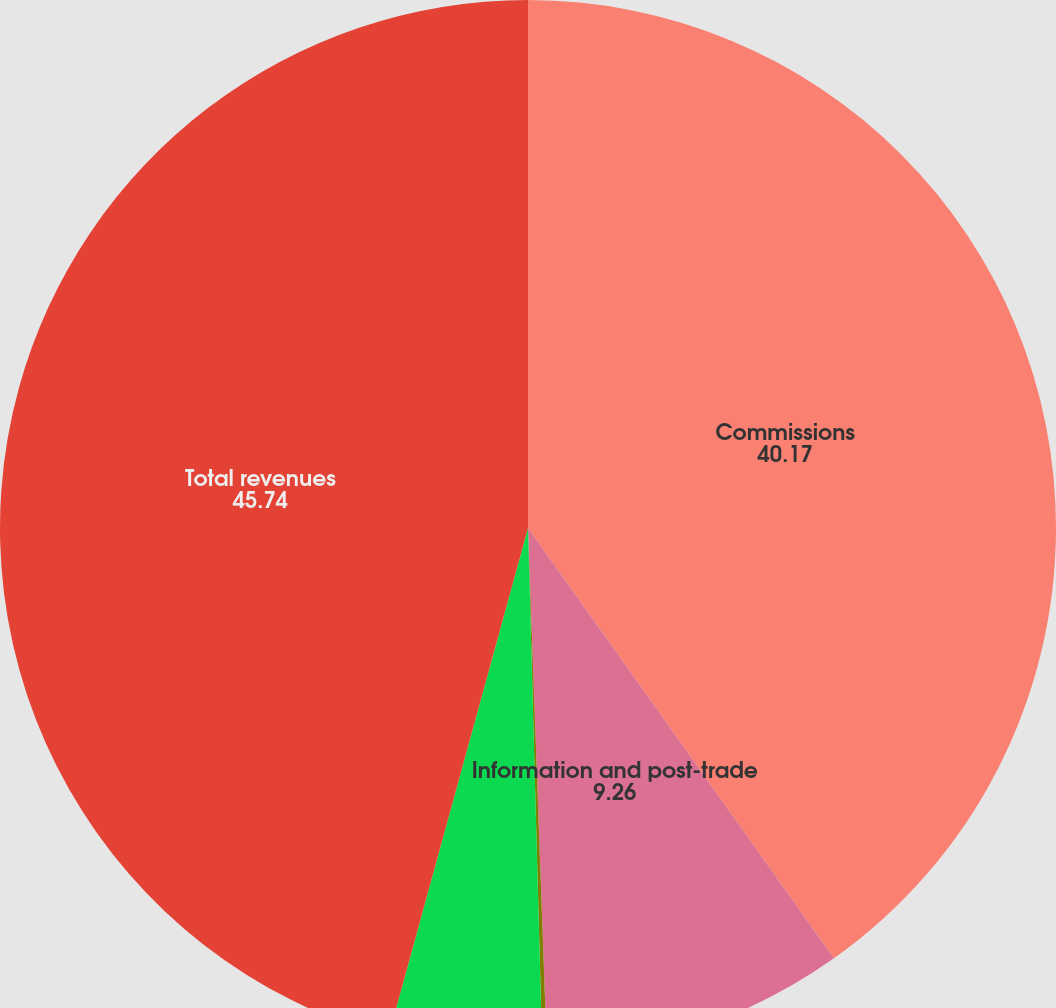Convert chart. <chart><loc_0><loc_0><loc_500><loc_500><pie_chart><fcel>Commissions<fcel>Information and post-trade<fcel>Investment income<fcel>Other<fcel>Total revenues<nl><fcel>40.17%<fcel>9.26%<fcel>0.14%<fcel>4.7%<fcel>45.74%<nl></chart> 